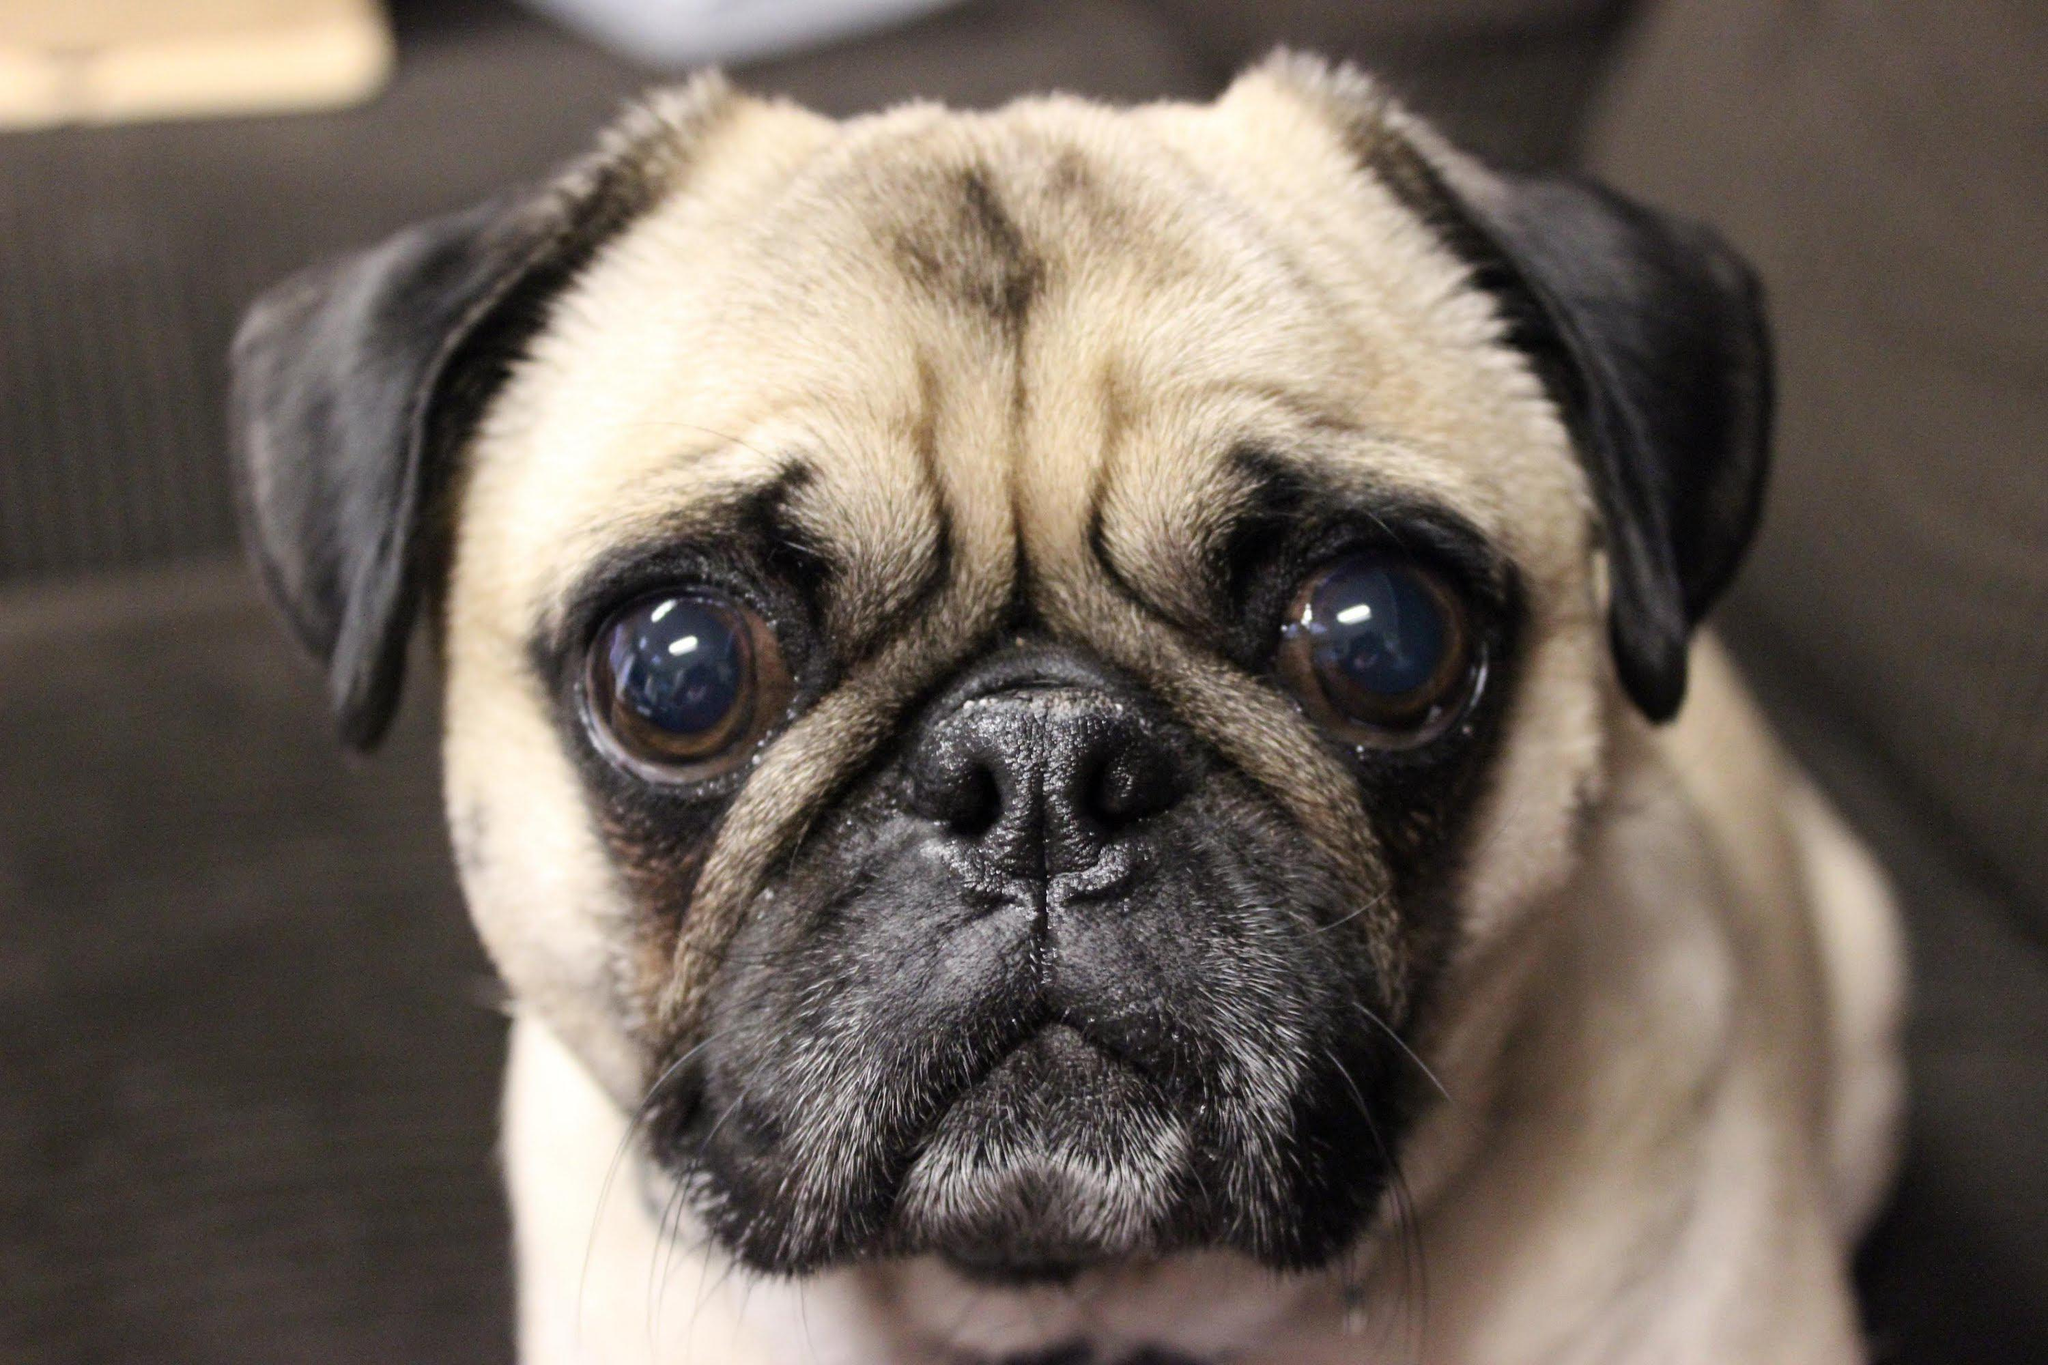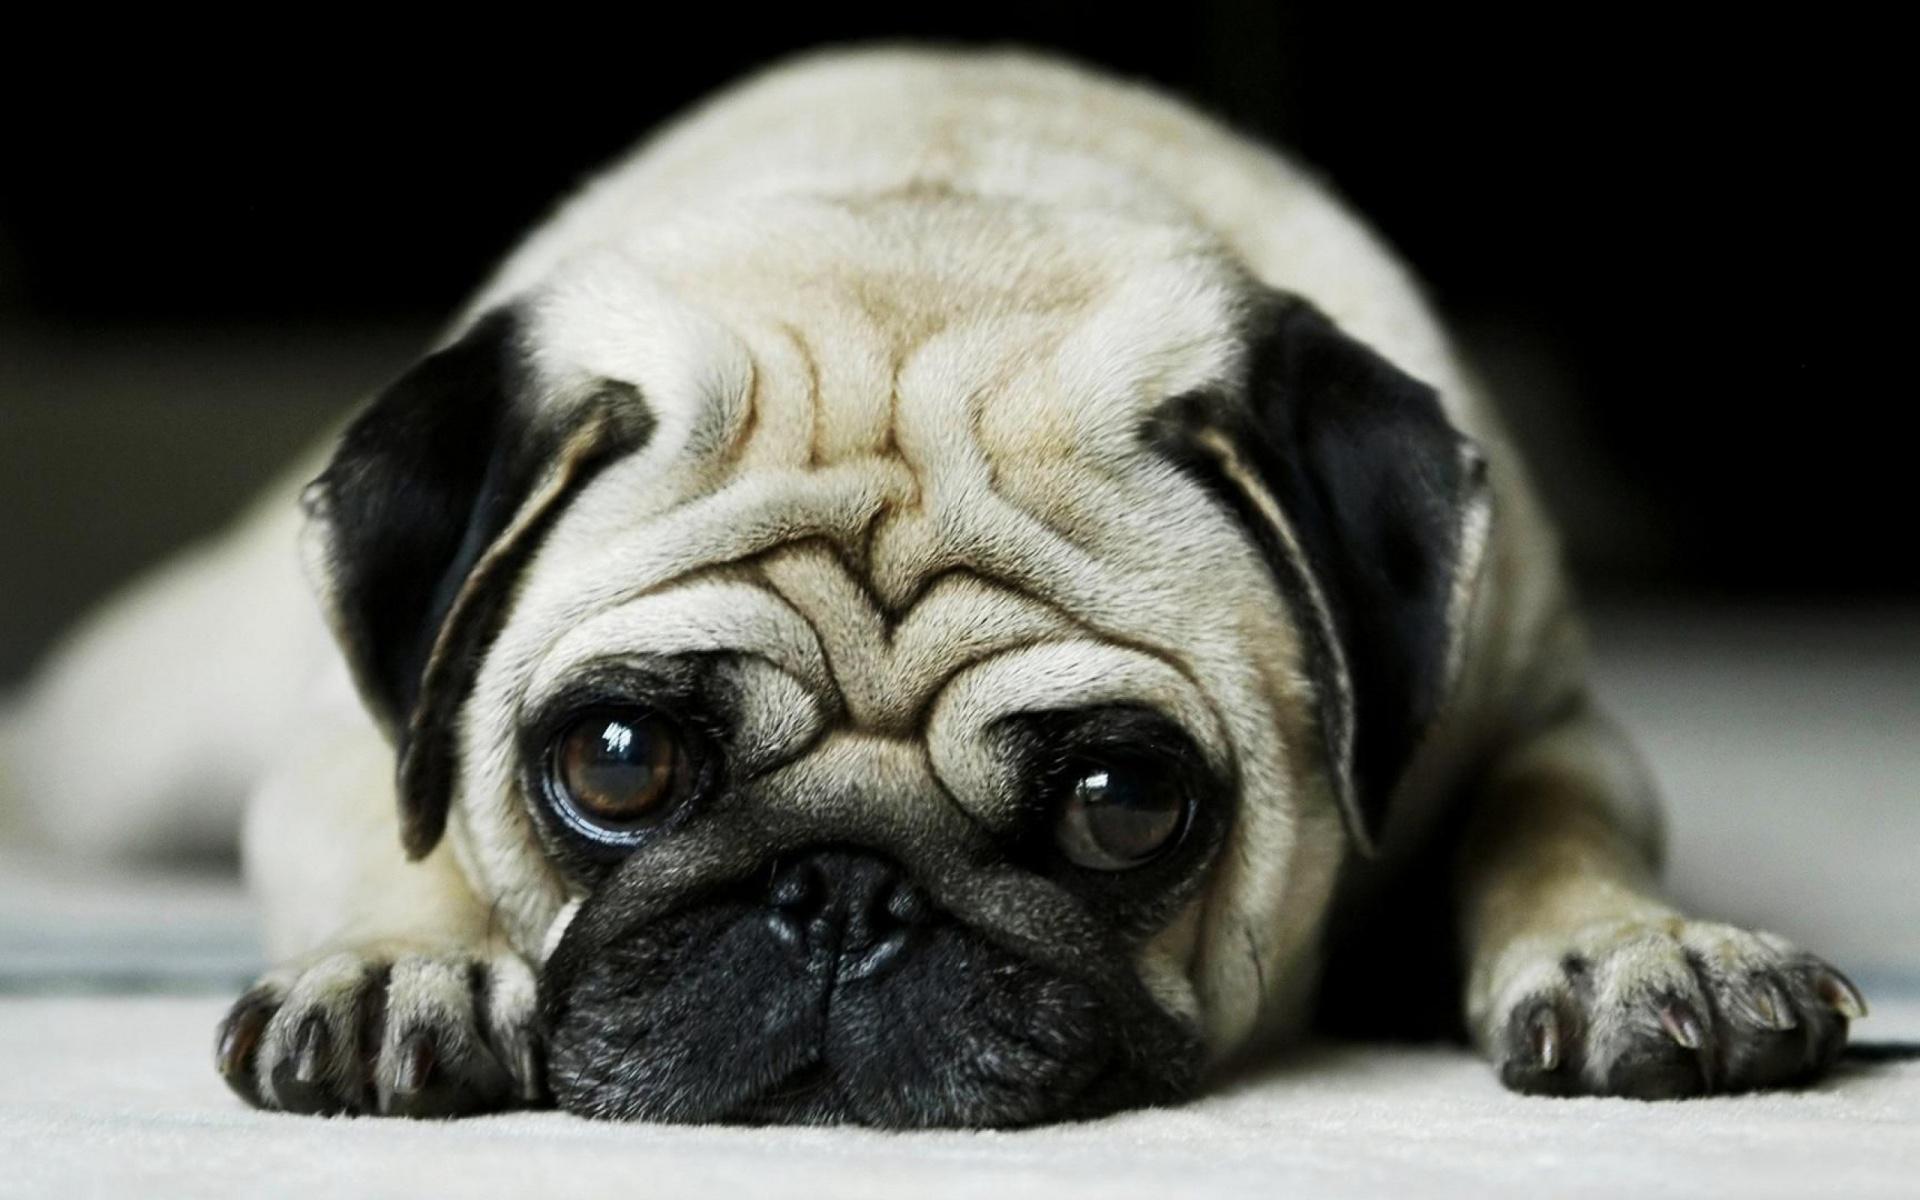The first image is the image on the left, the second image is the image on the right. Evaluate the accuracy of this statement regarding the images: "The pug reclining in the right image has paws extended in front.". Is it true? Answer yes or no. Yes. 